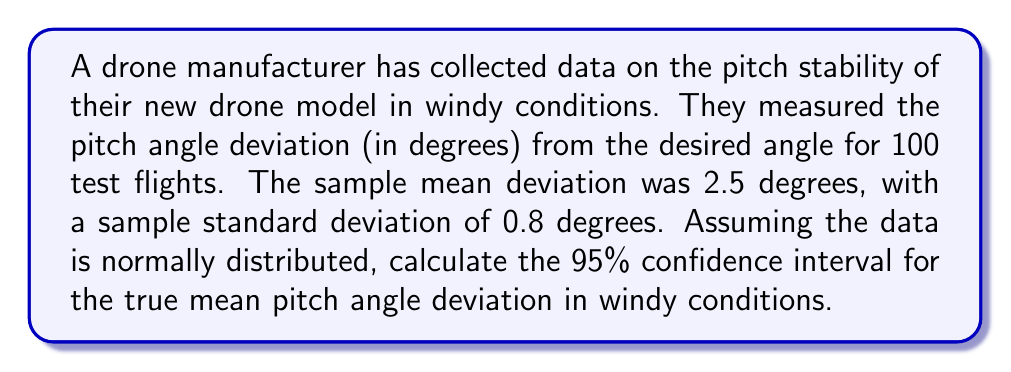Can you solve this math problem? To calculate the confidence interval, we'll follow these steps:

1. Identify the known values:
   - Sample size: $n = 100$
   - Sample mean: $\bar{x} = 2.5$ degrees
   - Sample standard deviation: $s = 0.8$ degrees
   - Confidence level: 95% (α = 0.05)

2. Determine the critical value:
   For a 95% confidence interval, we use the t-distribution with (n-1) degrees of freedom.
   With 99 degrees of freedom, the critical value is approximately $t_{0.025, 99} ≈ 1.984$

3. Calculate the margin of error:
   Margin of error = $t_{0.025, 99} \cdot \frac{s}{\sqrt{n}}$
   $= 1.984 \cdot \frac{0.8}{\sqrt{100}}$
   $= 1.984 \cdot 0.08$
   $= 0.15872$

4. Compute the confidence interval:
   Lower bound = $\bar{x} - \text{margin of error}$
   $= 2.5 - 0.15872 = 2.34128$

   Upper bound = $\bar{x} + \text{margin of error}$
   $= 2.5 + 0.15872 = 2.65872$

Therefore, the 95% confidence interval is (2.34128, 2.65872) degrees.
Answer: (2.34, 2.66) degrees 